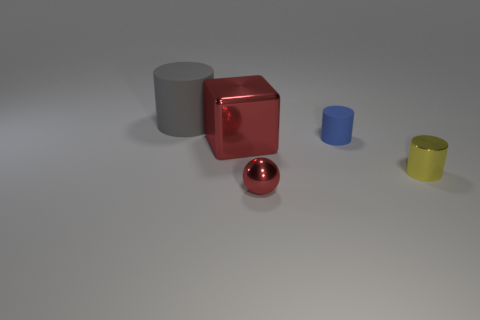Can you describe the lighting and shadows in the scene? The scene is illuminated with a soft light source from the upper right, creating gentle shadows to the left of the objects. The shadows are soft-edged, suggesting the light source is not overly harsh and is possibly diffused. 